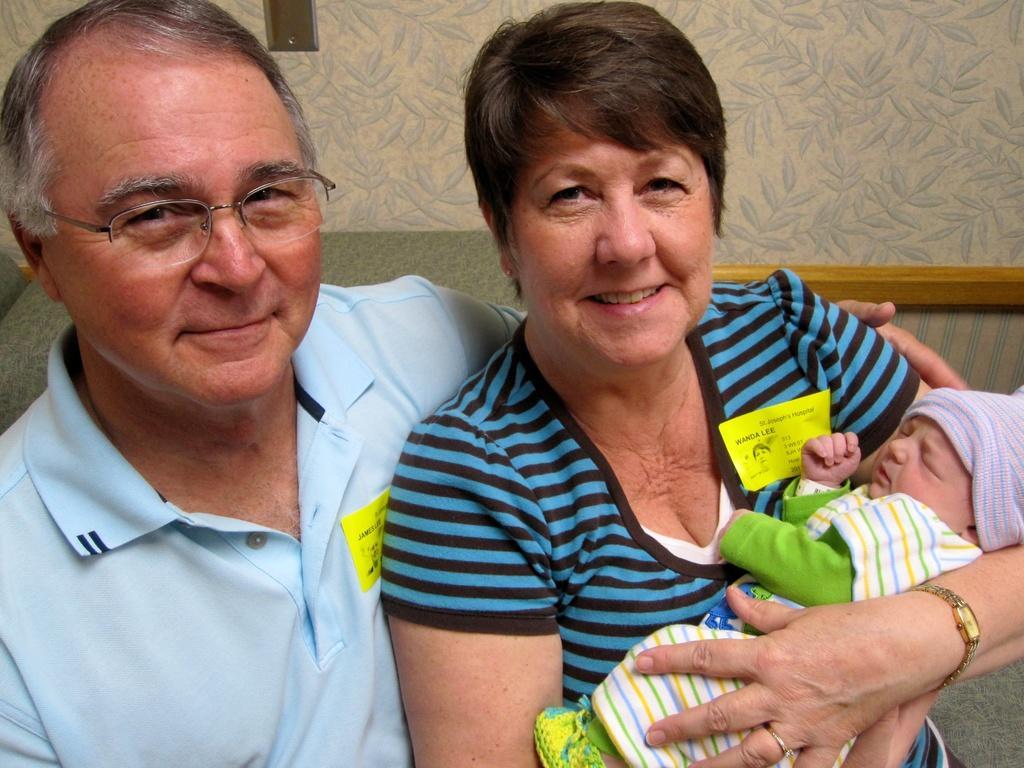Please provide a concise description of this image. In this picture we can see there are two people sitting on a couch and the woman is holding a baby. Behind the people there is a wall. 